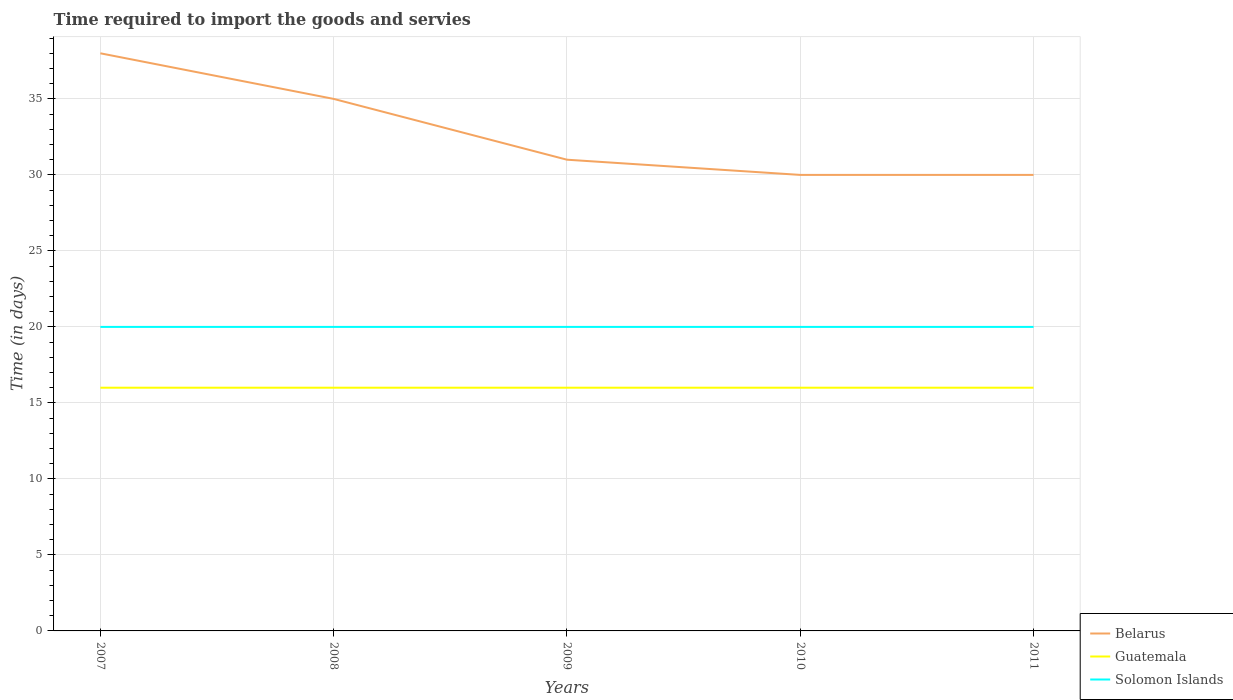How many different coloured lines are there?
Provide a short and direct response. 3. Does the line corresponding to Belarus intersect with the line corresponding to Solomon Islands?
Your answer should be very brief. No. Is the number of lines equal to the number of legend labels?
Keep it short and to the point. Yes. Across all years, what is the maximum number of days required to import the goods and services in Solomon Islands?
Offer a terse response. 20. What is the total number of days required to import the goods and services in Guatemala in the graph?
Your answer should be compact. 0. What is the difference between the highest and the lowest number of days required to import the goods and services in Solomon Islands?
Offer a very short reply. 0. Is the number of days required to import the goods and services in Guatemala strictly greater than the number of days required to import the goods and services in Belarus over the years?
Give a very brief answer. Yes. How many years are there in the graph?
Your answer should be very brief. 5. What is the difference between two consecutive major ticks on the Y-axis?
Your answer should be very brief. 5. Does the graph contain any zero values?
Ensure brevity in your answer.  No. Where does the legend appear in the graph?
Ensure brevity in your answer.  Bottom right. How many legend labels are there?
Ensure brevity in your answer.  3. What is the title of the graph?
Offer a terse response. Time required to import the goods and servies. What is the label or title of the Y-axis?
Provide a succinct answer. Time (in days). What is the Time (in days) in Belarus in 2007?
Give a very brief answer. 38. What is the Time (in days) of Solomon Islands in 2007?
Your answer should be very brief. 20. What is the Time (in days) of Belarus in 2010?
Your response must be concise. 30. What is the Time (in days) of Guatemala in 2010?
Provide a short and direct response. 16. What is the Time (in days) of Solomon Islands in 2011?
Your answer should be compact. 20. Across all years, what is the maximum Time (in days) of Belarus?
Make the answer very short. 38. Across all years, what is the maximum Time (in days) in Solomon Islands?
Your response must be concise. 20. Across all years, what is the minimum Time (in days) of Solomon Islands?
Keep it short and to the point. 20. What is the total Time (in days) in Belarus in the graph?
Keep it short and to the point. 164. What is the total Time (in days) in Solomon Islands in the graph?
Your response must be concise. 100. What is the difference between the Time (in days) of Belarus in 2007 and that in 2008?
Provide a short and direct response. 3. What is the difference between the Time (in days) in Guatemala in 2007 and that in 2008?
Your answer should be compact. 0. What is the difference between the Time (in days) in Solomon Islands in 2007 and that in 2008?
Your answer should be very brief. 0. What is the difference between the Time (in days) in Belarus in 2007 and that in 2009?
Provide a short and direct response. 7. What is the difference between the Time (in days) of Solomon Islands in 2007 and that in 2009?
Ensure brevity in your answer.  0. What is the difference between the Time (in days) in Guatemala in 2007 and that in 2010?
Offer a terse response. 0. What is the difference between the Time (in days) of Solomon Islands in 2007 and that in 2011?
Provide a succinct answer. 0. What is the difference between the Time (in days) of Belarus in 2008 and that in 2009?
Keep it short and to the point. 4. What is the difference between the Time (in days) in Guatemala in 2008 and that in 2010?
Offer a terse response. 0. What is the difference between the Time (in days) in Belarus in 2008 and that in 2011?
Make the answer very short. 5. What is the difference between the Time (in days) in Solomon Islands in 2008 and that in 2011?
Keep it short and to the point. 0. What is the difference between the Time (in days) of Belarus in 2009 and that in 2010?
Your answer should be compact. 1. What is the difference between the Time (in days) of Guatemala in 2009 and that in 2011?
Provide a short and direct response. 0. What is the difference between the Time (in days) of Guatemala in 2010 and that in 2011?
Your answer should be compact. 0. What is the difference between the Time (in days) of Solomon Islands in 2010 and that in 2011?
Make the answer very short. 0. What is the difference between the Time (in days) in Belarus in 2007 and the Time (in days) in Guatemala in 2008?
Ensure brevity in your answer.  22. What is the difference between the Time (in days) of Belarus in 2007 and the Time (in days) of Solomon Islands in 2008?
Give a very brief answer. 18. What is the difference between the Time (in days) in Belarus in 2007 and the Time (in days) in Guatemala in 2009?
Provide a succinct answer. 22. What is the difference between the Time (in days) in Guatemala in 2007 and the Time (in days) in Solomon Islands in 2009?
Keep it short and to the point. -4. What is the difference between the Time (in days) of Belarus in 2007 and the Time (in days) of Guatemala in 2011?
Give a very brief answer. 22. What is the difference between the Time (in days) in Belarus in 2007 and the Time (in days) in Solomon Islands in 2011?
Make the answer very short. 18. What is the difference between the Time (in days) in Guatemala in 2007 and the Time (in days) in Solomon Islands in 2011?
Keep it short and to the point. -4. What is the difference between the Time (in days) in Guatemala in 2008 and the Time (in days) in Solomon Islands in 2009?
Offer a very short reply. -4. What is the difference between the Time (in days) in Belarus in 2008 and the Time (in days) in Guatemala in 2011?
Ensure brevity in your answer.  19. What is the difference between the Time (in days) of Guatemala in 2008 and the Time (in days) of Solomon Islands in 2011?
Provide a short and direct response. -4. What is the difference between the Time (in days) of Belarus in 2009 and the Time (in days) of Guatemala in 2010?
Offer a very short reply. 15. What is the difference between the Time (in days) in Guatemala in 2009 and the Time (in days) in Solomon Islands in 2010?
Offer a very short reply. -4. What is the difference between the Time (in days) in Belarus in 2009 and the Time (in days) in Solomon Islands in 2011?
Provide a succinct answer. 11. What is the difference between the Time (in days) in Guatemala in 2009 and the Time (in days) in Solomon Islands in 2011?
Your answer should be compact. -4. What is the difference between the Time (in days) of Belarus in 2010 and the Time (in days) of Solomon Islands in 2011?
Offer a very short reply. 10. What is the average Time (in days) of Belarus per year?
Ensure brevity in your answer.  32.8. In the year 2007, what is the difference between the Time (in days) of Guatemala and Time (in days) of Solomon Islands?
Your answer should be very brief. -4. In the year 2008, what is the difference between the Time (in days) in Belarus and Time (in days) in Guatemala?
Give a very brief answer. 19. In the year 2009, what is the difference between the Time (in days) in Belarus and Time (in days) in Solomon Islands?
Offer a very short reply. 11. In the year 2009, what is the difference between the Time (in days) of Guatemala and Time (in days) of Solomon Islands?
Offer a very short reply. -4. In the year 2010, what is the difference between the Time (in days) of Belarus and Time (in days) of Solomon Islands?
Make the answer very short. 10. In the year 2011, what is the difference between the Time (in days) of Belarus and Time (in days) of Solomon Islands?
Offer a very short reply. 10. In the year 2011, what is the difference between the Time (in days) of Guatemala and Time (in days) of Solomon Islands?
Your answer should be very brief. -4. What is the ratio of the Time (in days) in Belarus in 2007 to that in 2008?
Your answer should be very brief. 1.09. What is the ratio of the Time (in days) in Solomon Islands in 2007 to that in 2008?
Make the answer very short. 1. What is the ratio of the Time (in days) in Belarus in 2007 to that in 2009?
Keep it short and to the point. 1.23. What is the ratio of the Time (in days) in Solomon Islands in 2007 to that in 2009?
Ensure brevity in your answer.  1. What is the ratio of the Time (in days) in Belarus in 2007 to that in 2010?
Ensure brevity in your answer.  1.27. What is the ratio of the Time (in days) of Guatemala in 2007 to that in 2010?
Offer a very short reply. 1. What is the ratio of the Time (in days) in Solomon Islands in 2007 to that in 2010?
Provide a short and direct response. 1. What is the ratio of the Time (in days) in Belarus in 2007 to that in 2011?
Provide a short and direct response. 1.27. What is the ratio of the Time (in days) in Guatemala in 2007 to that in 2011?
Offer a terse response. 1. What is the ratio of the Time (in days) of Solomon Islands in 2007 to that in 2011?
Give a very brief answer. 1. What is the ratio of the Time (in days) in Belarus in 2008 to that in 2009?
Your answer should be very brief. 1.13. What is the ratio of the Time (in days) of Guatemala in 2008 to that in 2009?
Make the answer very short. 1. What is the ratio of the Time (in days) in Solomon Islands in 2008 to that in 2009?
Offer a very short reply. 1. What is the ratio of the Time (in days) of Guatemala in 2008 to that in 2010?
Make the answer very short. 1. What is the ratio of the Time (in days) of Solomon Islands in 2008 to that in 2010?
Your response must be concise. 1. What is the ratio of the Time (in days) in Belarus in 2008 to that in 2011?
Provide a short and direct response. 1.17. What is the ratio of the Time (in days) in Guatemala in 2008 to that in 2011?
Offer a terse response. 1. What is the ratio of the Time (in days) of Solomon Islands in 2008 to that in 2011?
Ensure brevity in your answer.  1. What is the ratio of the Time (in days) of Belarus in 2009 to that in 2010?
Make the answer very short. 1.03. What is the ratio of the Time (in days) of Solomon Islands in 2009 to that in 2010?
Offer a terse response. 1. What is the ratio of the Time (in days) in Belarus in 2009 to that in 2011?
Provide a succinct answer. 1.03. What is the ratio of the Time (in days) of Guatemala in 2009 to that in 2011?
Give a very brief answer. 1. What is the ratio of the Time (in days) in Belarus in 2010 to that in 2011?
Offer a very short reply. 1. What is the difference between the highest and the second highest Time (in days) in Belarus?
Give a very brief answer. 3. What is the difference between the highest and the second highest Time (in days) in Solomon Islands?
Give a very brief answer. 0. What is the difference between the highest and the lowest Time (in days) of Guatemala?
Offer a very short reply. 0. 